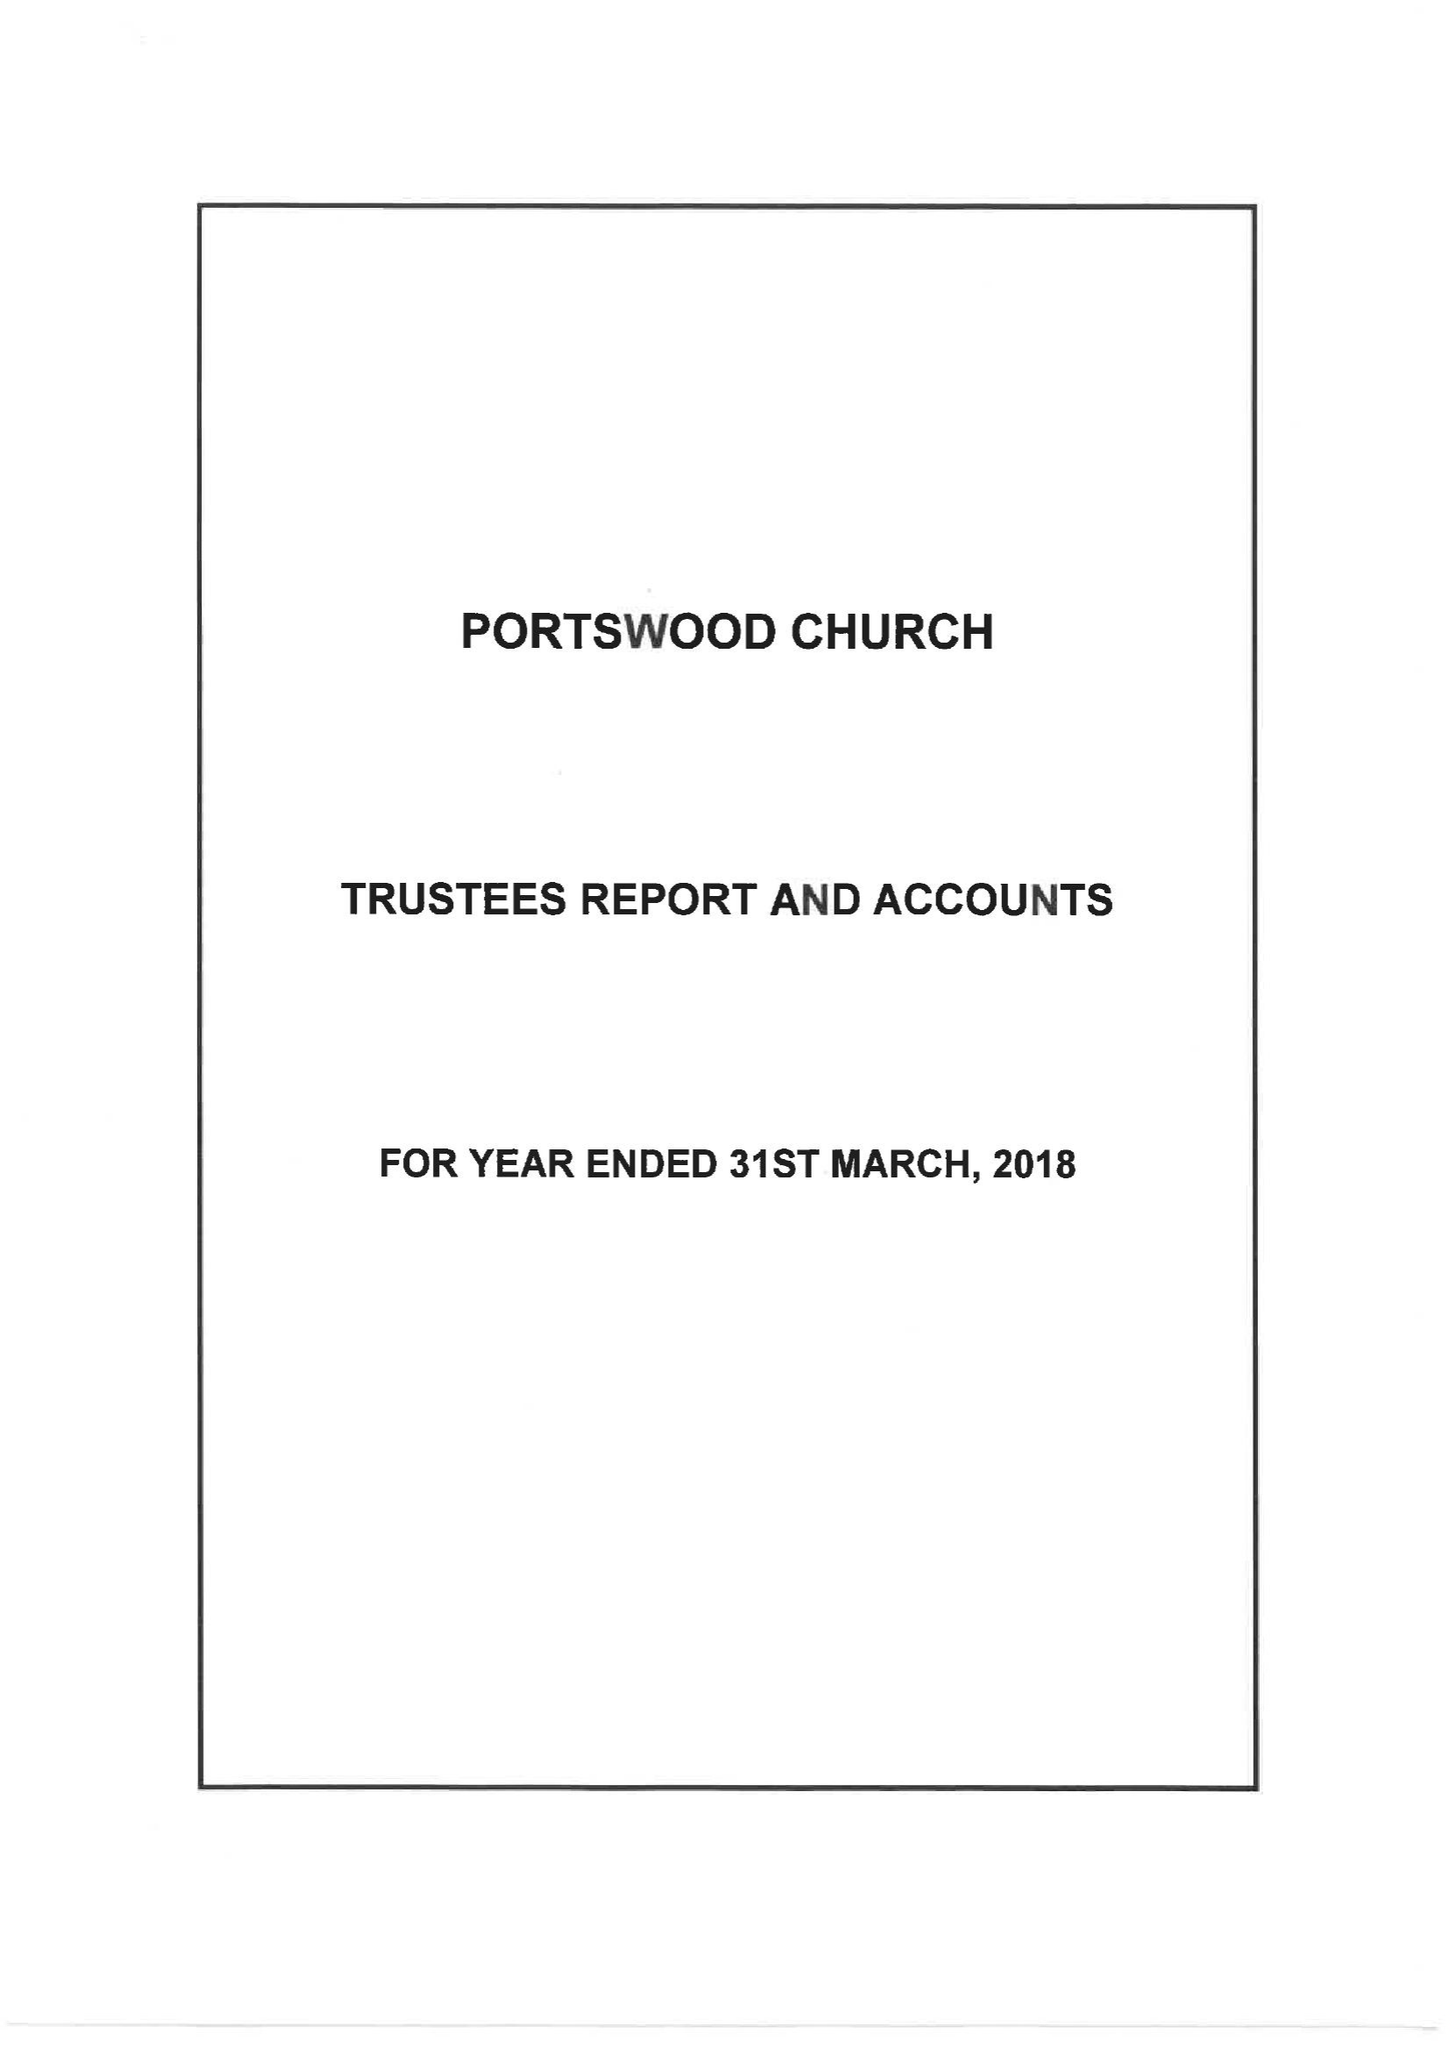What is the value for the charity_name?
Answer the question using a single word or phrase. Portswood Church 